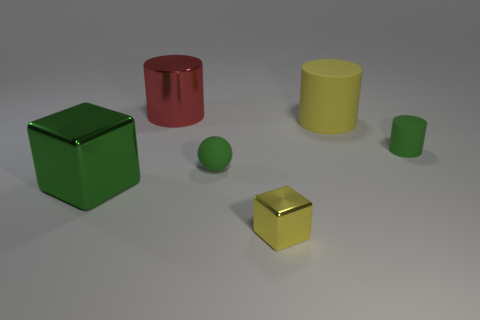How many objects are large cylinders right of the rubber ball or yellow things to the right of the yellow metallic block? There are no large cylinders to the right of the rubber ball. To the right of the yellow metallic block, there is one yellow object, which is a yellow cylinder. 